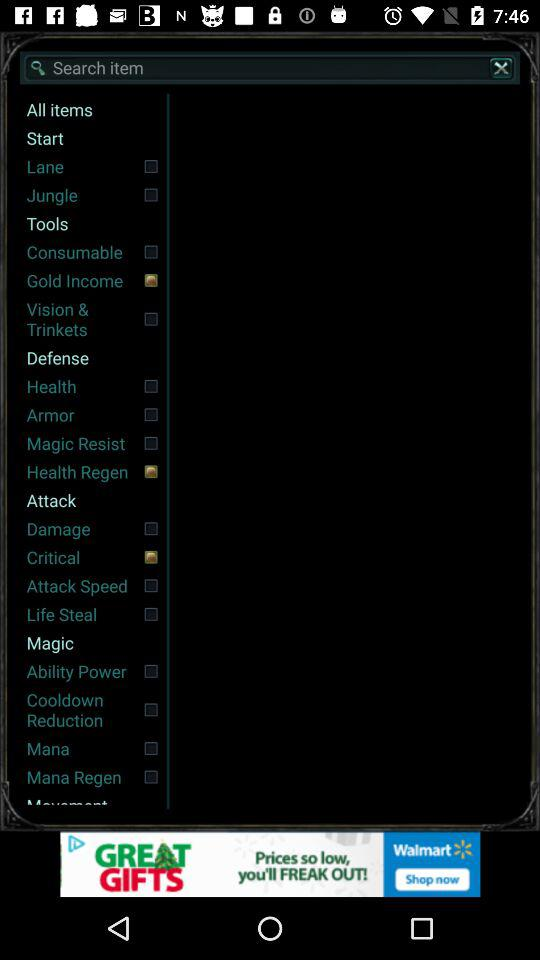What is typed into the search bar?
When the provided information is insufficient, respond with <no answer>. <no answer> 